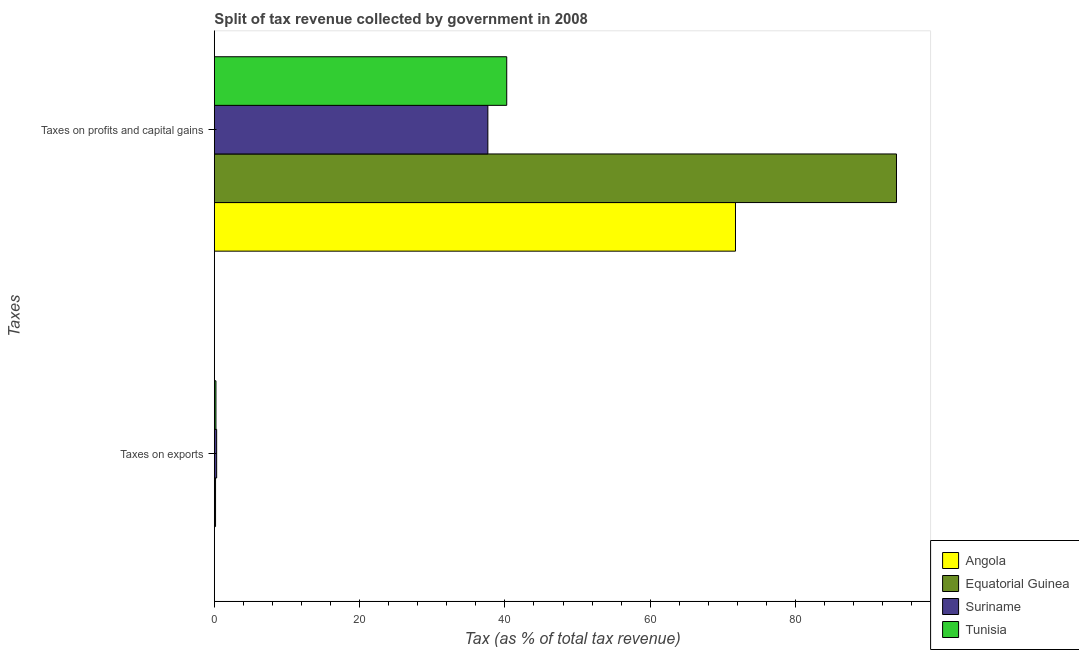How many different coloured bars are there?
Your answer should be very brief. 4. How many groups of bars are there?
Offer a very short reply. 2. Are the number of bars per tick equal to the number of legend labels?
Offer a terse response. Yes. Are the number of bars on each tick of the Y-axis equal?
Your answer should be compact. Yes. How many bars are there on the 2nd tick from the bottom?
Offer a very short reply. 4. What is the label of the 2nd group of bars from the top?
Ensure brevity in your answer.  Taxes on exports. What is the percentage of revenue obtained from taxes on profits and capital gains in Equatorial Guinea?
Provide a succinct answer. 93.9. Across all countries, what is the maximum percentage of revenue obtained from taxes on exports?
Provide a succinct answer. 0.32. Across all countries, what is the minimum percentage of revenue obtained from taxes on profits and capital gains?
Ensure brevity in your answer.  37.65. In which country was the percentage of revenue obtained from taxes on profits and capital gains maximum?
Your answer should be very brief. Equatorial Guinea. In which country was the percentage of revenue obtained from taxes on profits and capital gains minimum?
Provide a succinct answer. Suriname. What is the total percentage of revenue obtained from taxes on exports in the graph?
Make the answer very short. 0.71. What is the difference between the percentage of revenue obtained from taxes on exports in Equatorial Guinea and that in Angola?
Keep it short and to the point. 0.17. What is the difference between the percentage of revenue obtained from taxes on exports in Equatorial Guinea and the percentage of revenue obtained from taxes on profits and capital gains in Angola?
Your answer should be very brief. -71.58. What is the average percentage of revenue obtained from taxes on profits and capital gains per country?
Keep it short and to the point. 60.89. What is the difference between the percentage of revenue obtained from taxes on exports and percentage of revenue obtained from taxes on profits and capital gains in Angola?
Your response must be concise. -71.74. What is the ratio of the percentage of revenue obtained from taxes on exports in Equatorial Guinea to that in Tunisia?
Your response must be concise. 0.75. What does the 3rd bar from the top in Taxes on exports represents?
Give a very brief answer. Equatorial Guinea. What does the 3rd bar from the bottom in Taxes on exports represents?
Provide a short and direct response. Suriname. How many bars are there?
Ensure brevity in your answer.  8. Are all the bars in the graph horizontal?
Your answer should be very brief. Yes. Does the graph contain any zero values?
Provide a succinct answer. No. Where does the legend appear in the graph?
Your response must be concise. Bottom right. How are the legend labels stacked?
Offer a terse response. Vertical. What is the title of the graph?
Make the answer very short. Split of tax revenue collected by government in 2008. What is the label or title of the X-axis?
Keep it short and to the point. Tax (as % of total tax revenue). What is the label or title of the Y-axis?
Offer a very short reply. Taxes. What is the Tax (as % of total tax revenue) of Angola in Taxes on exports?
Your answer should be compact. 0. What is the Tax (as % of total tax revenue) of Equatorial Guinea in Taxes on exports?
Offer a terse response. 0.17. What is the Tax (as % of total tax revenue) of Suriname in Taxes on exports?
Your answer should be very brief. 0.32. What is the Tax (as % of total tax revenue) of Tunisia in Taxes on exports?
Offer a very short reply. 0.22. What is the Tax (as % of total tax revenue) of Angola in Taxes on profits and capital gains?
Offer a very short reply. 71.74. What is the Tax (as % of total tax revenue) of Equatorial Guinea in Taxes on profits and capital gains?
Keep it short and to the point. 93.9. What is the Tax (as % of total tax revenue) of Suriname in Taxes on profits and capital gains?
Your answer should be compact. 37.65. What is the Tax (as % of total tax revenue) of Tunisia in Taxes on profits and capital gains?
Keep it short and to the point. 40.25. Across all Taxes, what is the maximum Tax (as % of total tax revenue) of Angola?
Keep it short and to the point. 71.74. Across all Taxes, what is the maximum Tax (as % of total tax revenue) in Equatorial Guinea?
Your answer should be very brief. 93.9. Across all Taxes, what is the maximum Tax (as % of total tax revenue) in Suriname?
Offer a very short reply. 37.65. Across all Taxes, what is the maximum Tax (as % of total tax revenue) in Tunisia?
Ensure brevity in your answer.  40.25. Across all Taxes, what is the minimum Tax (as % of total tax revenue) in Angola?
Your response must be concise. 0. Across all Taxes, what is the minimum Tax (as % of total tax revenue) of Equatorial Guinea?
Offer a very short reply. 0.17. Across all Taxes, what is the minimum Tax (as % of total tax revenue) of Suriname?
Offer a very short reply. 0.32. Across all Taxes, what is the minimum Tax (as % of total tax revenue) in Tunisia?
Your response must be concise. 0.22. What is the total Tax (as % of total tax revenue) in Angola in the graph?
Make the answer very short. 71.74. What is the total Tax (as % of total tax revenue) in Equatorial Guinea in the graph?
Ensure brevity in your answer.  94.07. What is the total Tax (as % of total tax revenue) in Suriname in the graph?
Keep it short and to the point. 37.97. What is the total Tax (as % of total tax revenue) of Tunisia in the graph?
Provide a succinct answer. 40.47. What is the difference between the Tax (as % of total tax revenue) in Angola in Taxes on exports and that in Taxes on profits and capital gains?
Give a very brief answer. -71.74. What is the difference between the Tax (as % of total tax revenue) of Equatorial Guinea in Taxes on exports and that in Taxes on profits and capital gains?
Keep it short and to the point. -93.74. What is the difference between the Tax (as % of total tax revenue) in Suriname in Taxes on exports and that in Taxes on profits and capital gains?
Your answer should be compact. -37.34. What is the difference between the Tax (as % of total tax revenue) of Tunisia in Taxes on exports and that in Taxes on profits and capital gains?
Provide a succinct answer. -40.03. What is the difference between the Tax (as % of total tax revenue) of Angola in Taxes on exports and the Tax (as % of total tax revenue) of Equatorial Guinea in Taxes on profits and capital gains?
Provide a short and direct response. -93.9. What is the difference between the Tax (as % of total tax revenue) of Angola in Taxes on exports and the Tax (as % of total tax revenue) of Suriname in Taxes on profits and capital gains?
Offer a very short reply. -37.65. What is the difference between the Tax (as % of total tax revenue) in Angola in Taxes on exports and the Tax (as % of total tax revenue) in Tunisia in Taxes on profits and capital gains?
Give a very brief answer. -40.25. What is the difference between the Tax (as % of total tax revenue) in Equatorial Guinea in Taxes on exports and the Tax (as % of total tax revenue) in Suriname in Taxes on profits and capital gains?
Provide a short and direct response. -37.49. What is the difference between the Tax (as % of total tax revenue) in Equatorial Guinea in Taxes on exports and the Tax (as % of total tax revenue) in Tunisia in Taxes on profits and capital gains?
Your response must be concise. -40.09. What is the difference between the Tax (as % of total tax revenue) of Suriname in Taxes on exports and the Tax (as % of total tax revenue) of Tunisia in Taxes on profits and capital gains?
Offer a very short reply. -39.93. What is the average Tax (as % of total tax revenue) in Angola per Taxes?
Your response must be concise. 35.87. What is the average Tax (as % of total tax revenue) in Equatorial Guinea per Taxes?
Ensure brevity in your answer.  47.04. What is the average Tax (as % of total tax revenue) of Suriname per Taxes?
Your answer should be very brief. 18.99. What is the average Tax (as % of total tax revenue) in Tunisia per Taxes?
Provide a succinct answer. 20.24. What is the difference between the Tax (as % of total tax revenue) of Angola and Tax (as % of total tax revenue) of Equatorial Guinea in Taxes on exports?
Your answer should be very brief. -0.17. What is the difference between the Tax (as % of total tax revenue) of Angola and Tax (as % of total tax revenue) of Suriname in Taxes on exports?
Provide a short and direct response. -0.32. What is the difference between the Tax (as % of total tax revenue) of Angola and Tax (as % of total tax revenue) of Tunisia in Taxes on exports?
Give a very brief answer. -0.22. What is the difference between the Tax (as % of total tax revenue) of Equatorial Guinea and Tax (as % of total tax revenue) of Suriname in Taxes on exports?
Your answer should be very brief. -0.15. What is the difference between the Tax (as % of total tax revenue) in Equatorial Guinea and Tax (as % of total tax revenue) in Tunisia in Taxes on exports?
Make the answer very short. -0.06. What is the difference between the Tax (as % of total tax revenue) of Suriname and Tax (as % of total tax revenue) of Tunisia in Taxes on exports?
Offer a terse response. 0.1. What is the difference between the Tax (as % of total tax revenue) of Angola and Tax (as % of total tax revenue) of Equatorial Guinea in Taxes on profits and capital gains?
Your response must be concise. -22.16. What is the difference between the Tax (as % of total tax revenue) of Angola and Tax (as % of total tax revenue) of Suriname in Taxes on profits and capital gains?
Keep it short and to the point. 34.09. What is the difference between the Tax (as % of total tax revenue) of Angola and Tax (as % of total tax revenue) of Tunisia in Taxes on profits and capital gains?
Ensure brevity in your answer.  31.49. What is the difference between the Tax (as % of total tax revenue) in Equatorial Guinea and Tax (as % of total tax revenue) in Suriname in Taxes on profits and capital gains?
Provide a succinct answer. 56.25. What is the difference between the Tax (as % of total tax revenue) of Equatorial Guinea and Tax (as % of total tax revenue) of Tunisia in Taxes on profits and capital gains?
Give a very brief answer. 53.65. What is the difference between the Tax (as % of total tax revenue) in Suriname and Tax (as % of total tax revenue) in Tunisia in Taxes on profits and capital gains?
Provide a succinct answer. -2.6. What is the ratio of the Tax (as % of total tax revenue) of Equatorial Guinea in Taxes on exports to that in Taxes on profits and capital gains?
Offer a terse response. 0. What is the ratio of the Tax (as % of total tax revenue) in Suriname in Taxes on exports to that in Taxes on profits and capital gains?
Your answer should be compact. 0.01. What is the ratio of the Tax (as % of total tax revenue) in Tunisia in Taxes on exports to that in Taxes on profits and capital gains?
Provide a succinct answer. 0.01. What is the difference between the highest and the second highest Tax (as % of total tax revenue) of Angola?
Make the answer very short. 71.74. What is the difference between the highest and the second highest Tax (as % of total tax revenue) in Equatorial Guinea?
Make the answer very short. 93.74. What is the difference between the highest and the second highest Tax (as % of total tax revenue) of Suriname?
Provide a short and direct response. 37.34. What is the difference between the highest and the second highest Tax (as % of total tax revenue) of Tunisia?
Offer a very short reply. 40.03. What is the difference between the highest and the lowest Tax (as % of total tax revenue) of Angola?
Give a very brief answer. 71.74. What is the difference between the highest and the lowest Tax (as % of total tax revenue) in Equatorial Guinea?
Give a very brief answer. 93.74. What is the difference between the highest and the lowest Tax (as % of total tax revenue) in Suriname?
Offer a terse response. 37.34. What is the difference between the highest and the lowest Tax (as % of total tax revenue) of Tunisia?
Offer a very short reply. 40.03. 